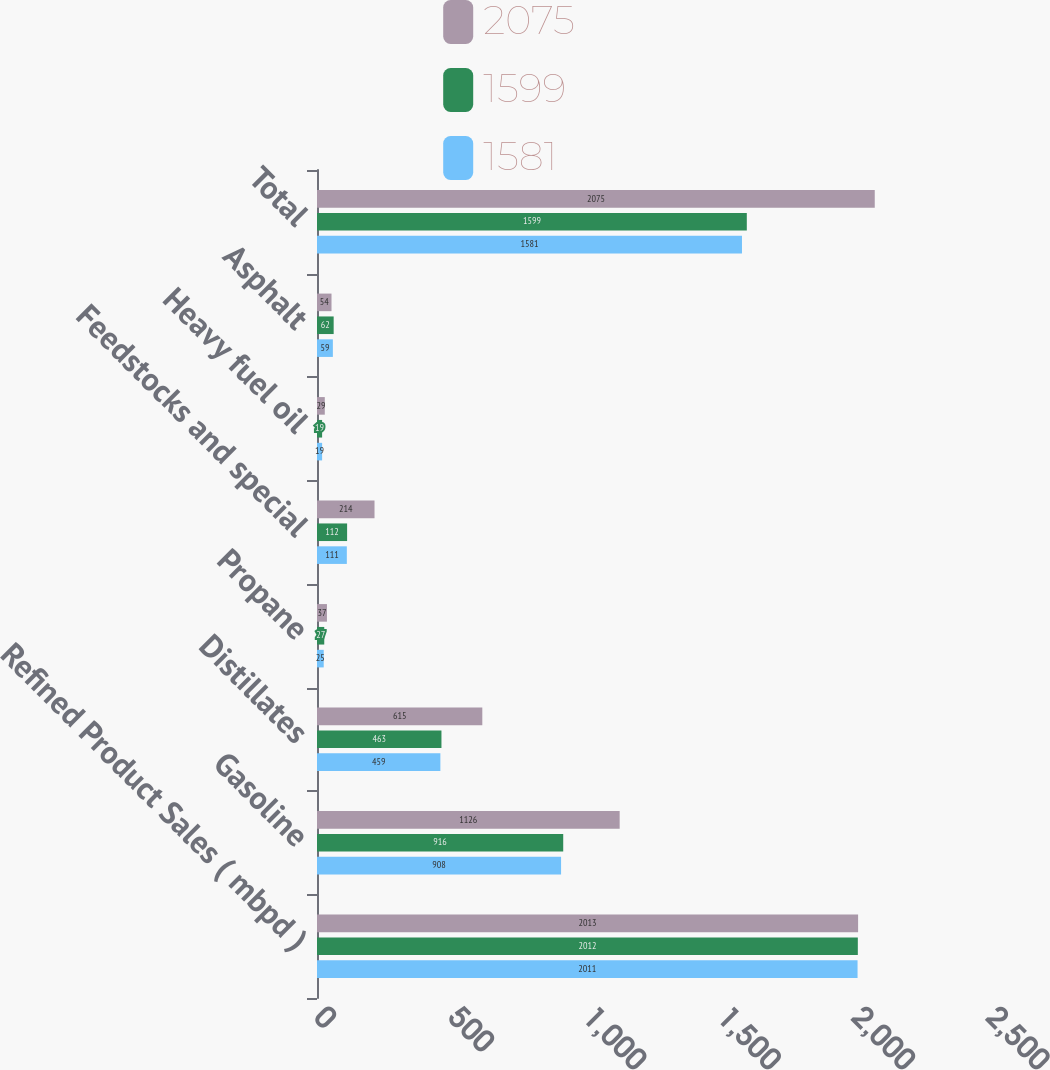Convert chart to OTSL. <chart><loc_0><loc_0><loc_500><loc_500><stacked_bar_chart><ecel><fcel>Refined Product Sales ( mbpd )<fcel>Gasoline<fcel>Distillates<fcel>Propane<fcel>Feedstocks and special<fcel>Heavy fuel oil<fcel>Asphalt<fcel>Total<nl><fcel>2075<fcel>2013<fcel>1126<fcel>615<fcel>37<fcel>214<fcel>29<fcel>54<fcel>2075<nl><fcel>1599<fcel>2012<fcel>916<fcel>463<fcel>27<fcel>112<fcel>19<fcel>62<fcel>1599<nl><fcel>1581<fcel>2011<fcel>908<fcel>459<fcel>25<fcel>111<fcel>19<fcel>59<fcel>1581<nl></chart> 